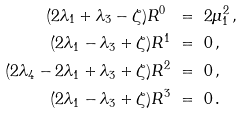Convert formula to latex. <formula><loc_0><loc_0><loc_500><loc_500>( 2 \lambda _ { 1 } + \lambda _ { 3 } - \zeta ) R ^ { 0 } \ & = \ 2 \mu _ { 1 } ^ { 2 } \, , \\ ( 2 \lambda _ { 1 } - \lambda _ { 3 } + \zeta ) R ^ { 1 } \ & = \ 0 \, , \\ ( 2 \lambda _ { 4 } - 2 \lambda _ { 1 } + \lambda _ { 3 } + \zeta ) R ^ { 2 } \ & = \ 0 \, , \\ ( 2 \lambda _ { 1 } - \lambda _ { 3 } + \zeta ) R ^ { 3 } \ & = \ 0 \, .</formula> 